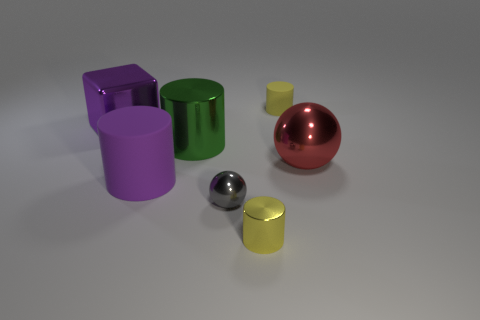Can you compare the sizes of the red and yellow objects? Certainly, the red sphere appears larger than the yellow cylinder. The red sphere's size gives it a prominent presence in the image, while the yellow cylinder seems smaller and less prominent. 